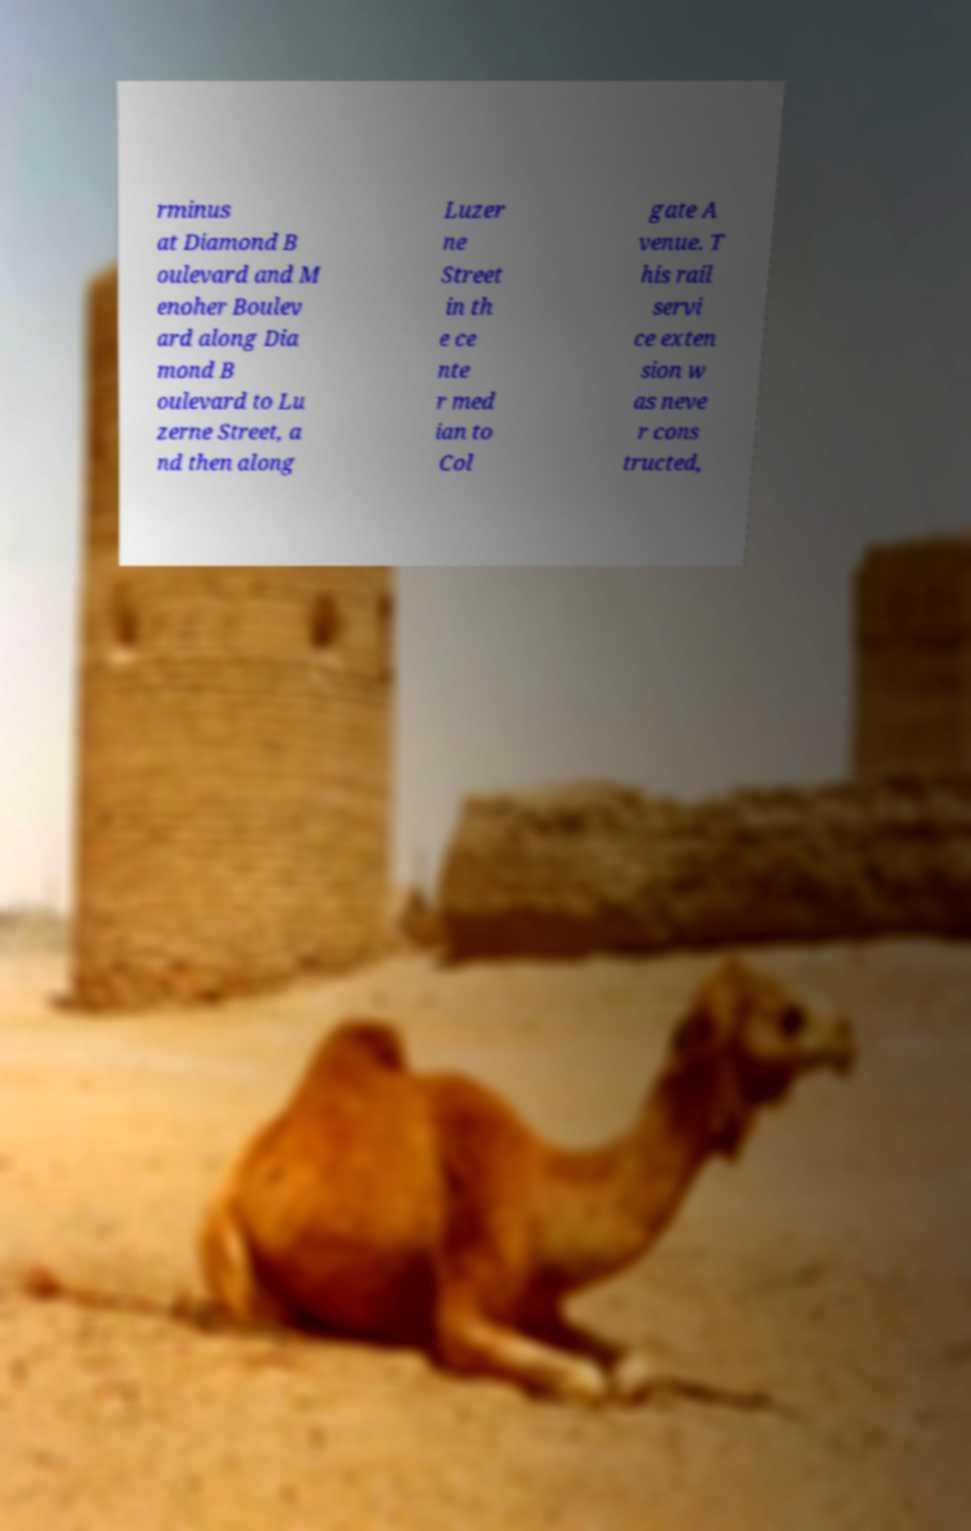Please read and relay the text visible in this image. What does it say? rminus at Diamond B oulevard and M enoher Boulev ard along Dia mond B oulevard to Lu zerne Street, a nd then along Luzer ne Street in th e ce nte r med ian to Col gate A venue. T his rail servi ce exten sion w as neve r cons tructed, 